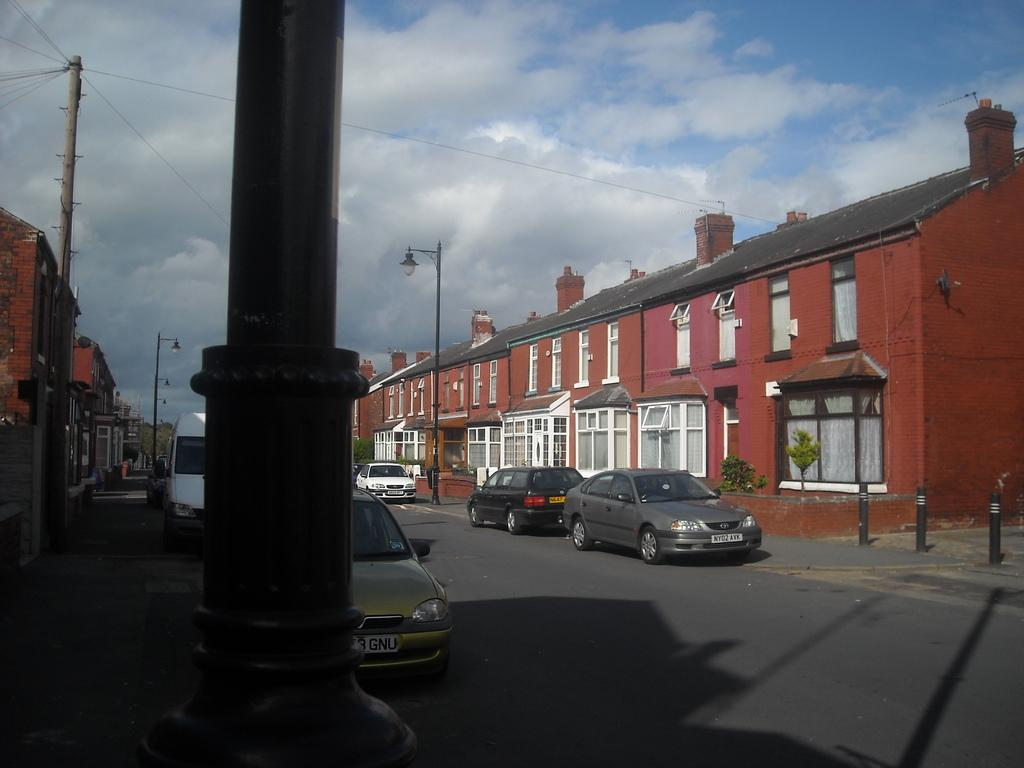What can be seen on the road in the image? There are vehicles on the road in the image. What is present near the road in the image? There is a pole and light poles in the image. What is the weather like in the image? The sky is cloudy in the image. What type of structures are visible in the image? There are buildings in the image. What type of vegetation is present in the image? There are plants in the image. What feature can be seen on the buildings in the image? The buildings have windows. Can you tell me how many scales are visible on the vehicles in the image? There are no scales present on the vehicles in the image. What type of van can be seen driving on the road in the image? There is no van present on the road in the image. 